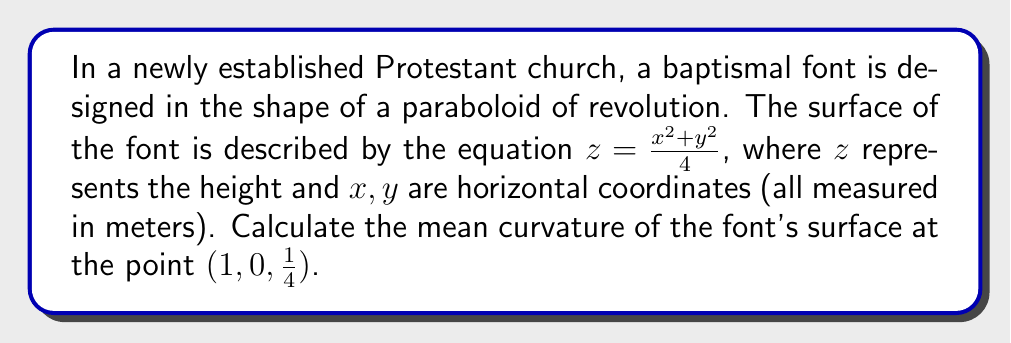Show me your answer to this math problem. To find the mean curvature of the paraboloid surface, we'll follow these steps:

1) The mean curvature $H$ is given by:

   $$H = \frac{1}{2}(\kappa_1 + \kappa_2)$$

   where $\kappa_1$ and $\kappa_2$ are the principal curvatures.

2) For a surface $z = f(x,y)$, the mean curvature is:

   $$H = \frac{(1+f_y^2)f_{xx} - 2f_xf_yf_{xy} + (1+f_x^2)f_{yy}}{2(1+f_x^2+f_y^2)^{3/2}}$$

3) For our paraboloid $z = \frac{x^2 + y^2}{4}$, we need to calculate:

   $f_x = \frac{x}{2}$, $f_y = \frac{y}{2}$
   $f_{xx} = \frac{1}{2}$, $f_{yy} = \frac{1}{2}$, $f_{xy} = 0$

4) At the point $(1,0,\frac{1}{4})$:

   $f_x = \frac{1}{2}$, $f_y = 0$
   $f_{xx} = f_{yy} = \frac{1}{2}$, $f_{xy} = 0$

5) Substituting into the mean curvature formula:

   $$H = \frac{(1+0^2)\frac{1}{2} - 2\cdot\frac{1}{2}\cdot0\cdot0 + (1+(\frac{1}{2})^2)\frac{1}{2}}{2(1+(\frac{1}{2})^2+0^2)^{3/2}}$$

6) Simplifying:

   $$H = \frac{\frac{1}{2} + \frac{5}{8}}{2(1+\frac{1}{4})^{3/2}} = \frac{\frac{9}{8}}{2(\frac{5}{4})^{3/2}}$$

7) Further simplification:

   $$H = \frac{9}{8} \cdot \frac{2}{5^{3/2}} \cdot \frac{2}{2} = \frac{9}{20\sqrt{5}}$$
Answer: $\frac{9}{20\sqrt{5}}$ m^(-1) 